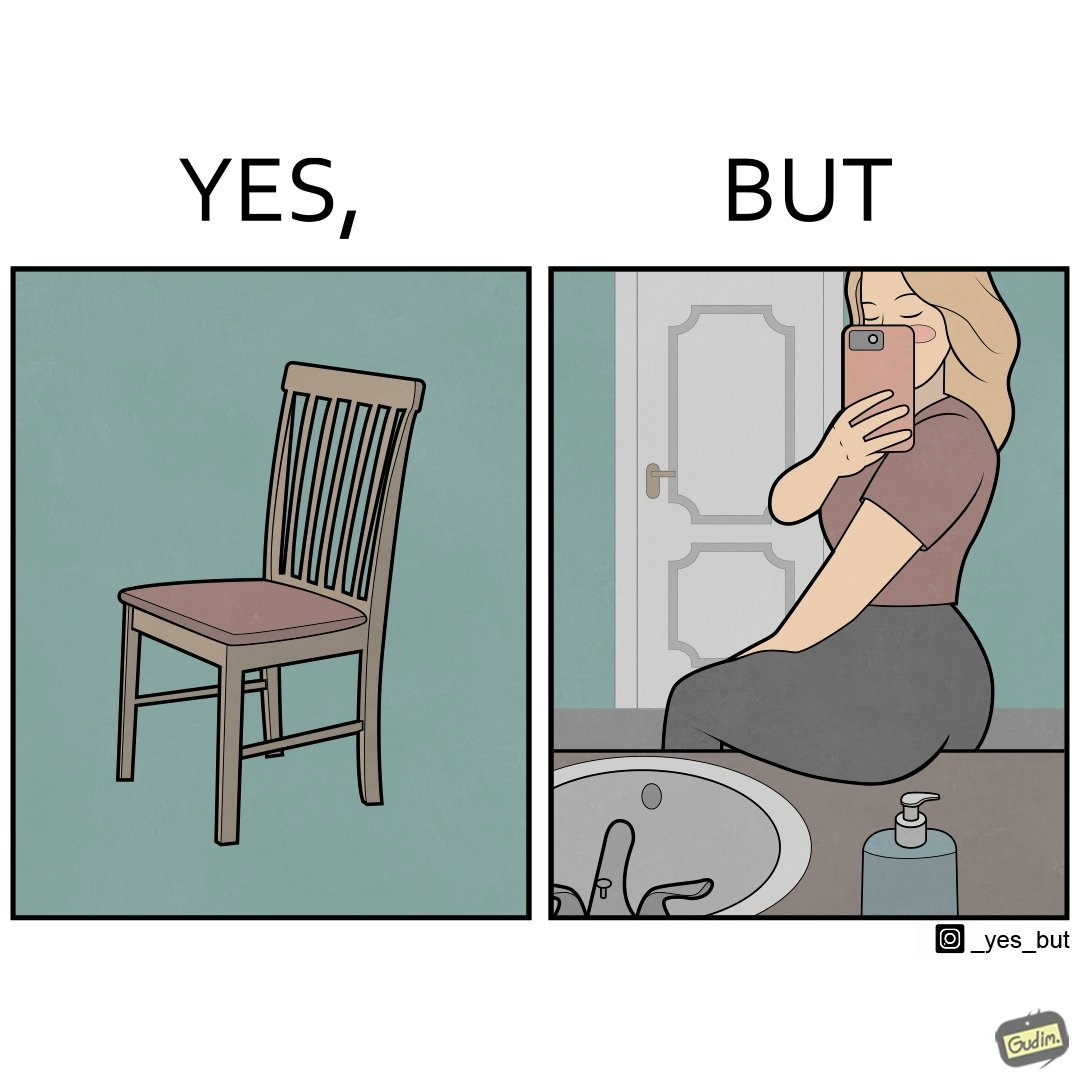Would you classify this image as satirical? Yes, this image is satirical. 